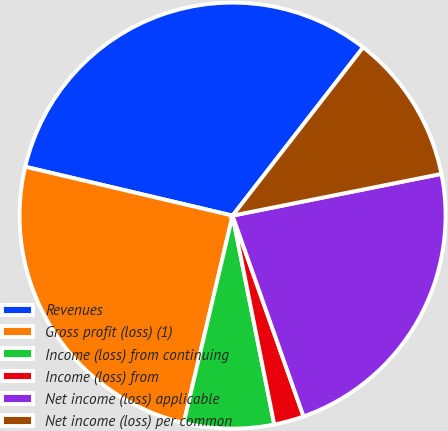<chart> <loc_0><loc_0><loc_500><loc_500><pie_chart><fcel>Revenues<fcel>Gross profit (loss) (1)<fcel>Income (loss) from continuing<fcel>Income (loss) from<fcel>Net income (loss) applicable<fcel>Net income (loss) per common<nl><fcel>31.82%<fcel>25.0%<fcel>6.82%<fcel>2.27%<fcel>22.73%<fcel>11.36%<nl></chart> 